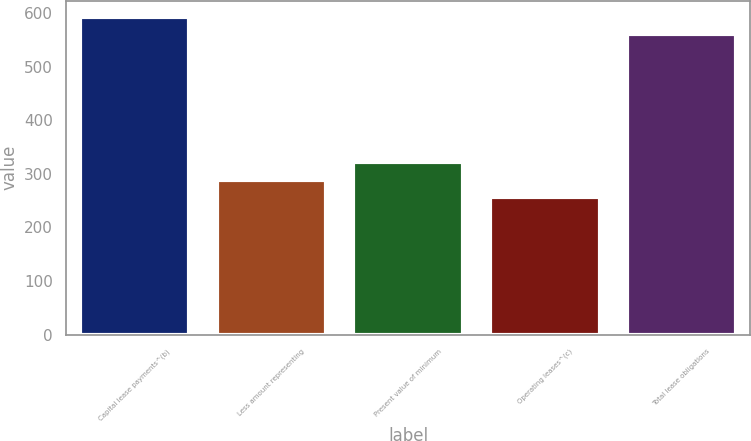<chart> <loc_0><loc_0><loc_500><loc_500><bar_chart><fcel>Capital lease payments^(b)<fcel>Less amount representing<fcel>Present value of minimum<fcel>Operating leases^(c)<fcel>Total lease obligations<nl><fcel>593.2<fcel>289.2<fcel>322.4<fcel>256<fcel>560<nl></chart> 